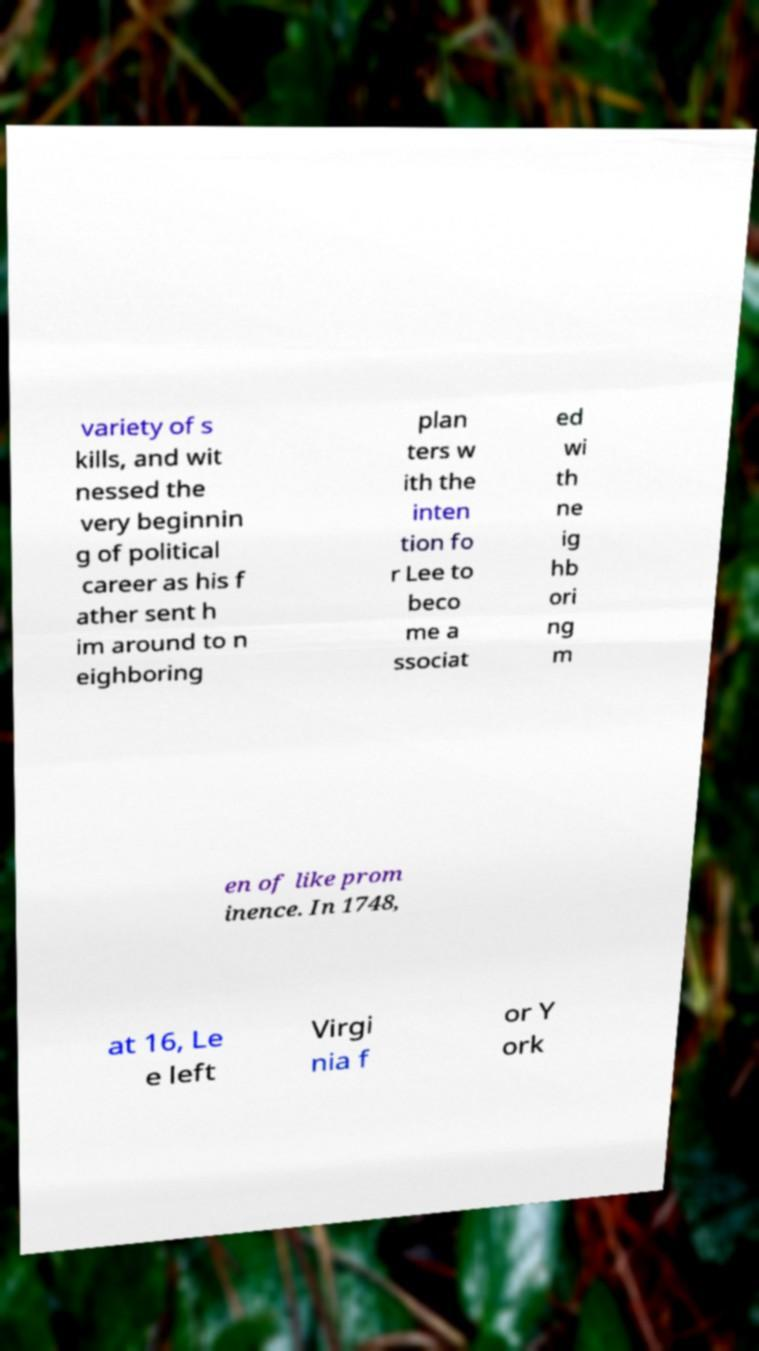Can you read and provide the text displayed in the image?This photo seems to have some interesting text. Can you extract and type it out for me? variety of s kills, and wit nessed the very beginnin g of political career as his f ather sent h im around to n eighboring plan ters w ith the inten tion fo r Lee to beco me a ssociat ed wi th ne ig hb ori ng m en of like prom inence. In 1748, at 16, Le e left Virgi nia f or Y ork 